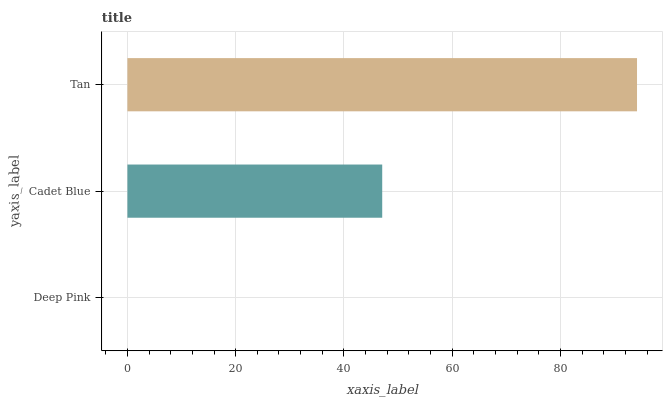Is Deep Pink the minimum?
Answer yes or no. Yes. Is Tan the maximum?
Answer yes or no. Yes. Is Cadet Blue the minimum?
Answer yes or no. No. Is Cadet Blue the maximum?
Answer yes or no. No. Is Cadet Blue greater than Deep Pink?
Answer yes or no. Yes. Is Deep Pink less than Cadet Blue?
Answer yes or no. Yes. Is Deep Pink greater than Cadet Blue?
Answer yes or no. No. Is Cadet Blue less than Deep Pink?
Answer yes or no. No. Is Cadet Blue the high median?
Answer yes or no. Yes. Is Cadet Blue the low median?
Answer yes or no. Yes. Is Tan the high median?
Answer yes or no. No. Is Tan the low median?
Answer yes or no. No. 